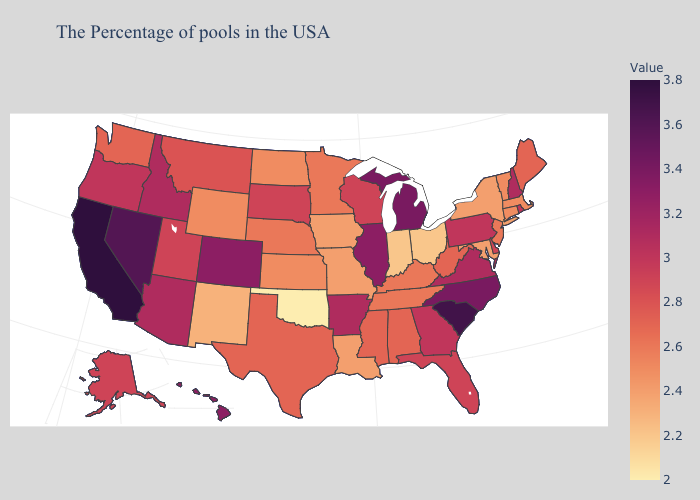Does Alaska have the highest value in the West?
Answer briefly. No. Among the states that border Illinois , does Wisconsin have the lowest value?
Be succinct. No. Which states hav the highest value in the South?
Give a very brief answer. South Carolina. Which states have the lowest value in the USA?
Quick response, please. Oklahoma. Does Alabama have a lower value than South Carolina?
Short answer required. Yes. Does New Mexico have the lowest value in the West?
Short answer required. Yes. Does Hawaii have a higher value than Nevada?
Quick response, please. No. Does the map have missing data?
Short answer required. No. Among the states that border Utah , does Nevada have the lowest value?
Concise answer only. No. Which states have the lowest value in the South?
Keep it brief. Oklahoma. Which states hav the highest value in the Northeast?
Write a very short answer. New Hampshire. 